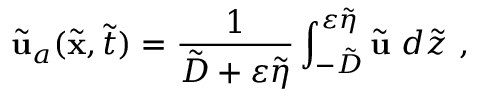<formula> <loc_0><loc_0><loc_500><loc_500>\tilde { u } _ { a } ( \tilde { x } , \tilde { t } ) = \frac { 1 } { \tilde { D } + \varepsilon \tilde { \eta } } \int _ { - \tilde { D } } ^ { \varepsilon \tilde { \eta } } \tilde { u } d \tilde { z } \ ,</formula> 